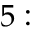Convert formula to latex. <formula><loc_0><loc_0><loc_500><loc_500>5 \colon</formula> 